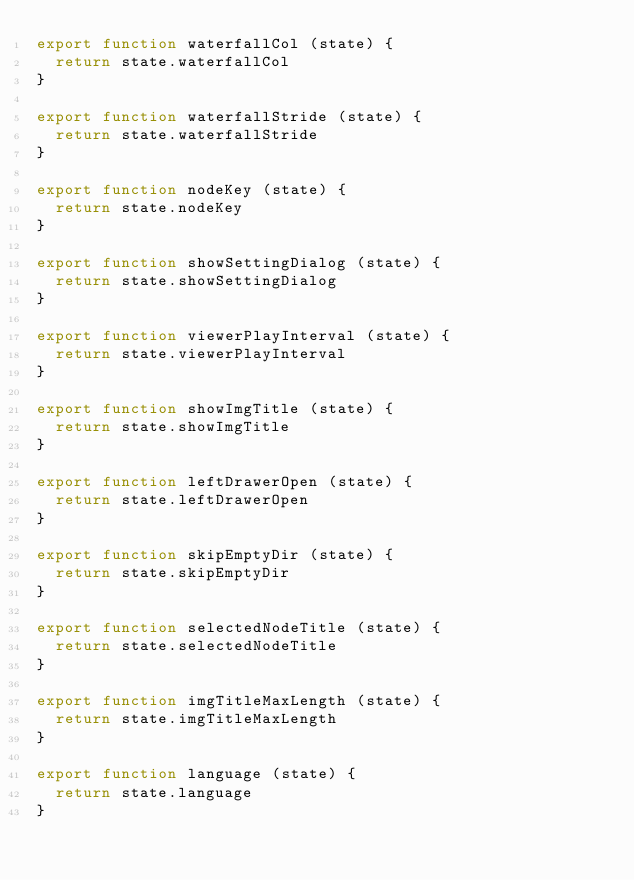<code> <loc_0><loc_0><loc_500><loc_500><_JavaScript_>export function waterfallCol (state) {
  return state.waterfallCol
}

export function waterfallStride (state) {
  return state.waterfallStride
}

export function nodeKey (state) {
  return state.nodeKey
}

export function showSettingDialog (state) {
  return state.showSettingDialog
}

export function viewerPlayInterval (state) {
  return state.viewerPlayInterval
}

export function showImgTitle (state) {
  return state.showImgTitle
}

export function leftDrawerOpen (state) {
  return state.leftDrawerOpen
}

export function skipEmptyDir (state) {
  return state.skipEmptyDir
}

export function selectedNodeTitle (state) {
  return state.selectedNodeTitle
}

export function imgTitleMaxLength (state) {
  return state.imgTitleMaxLength
}

export function language (state) {
  return state.language
}
</code> 